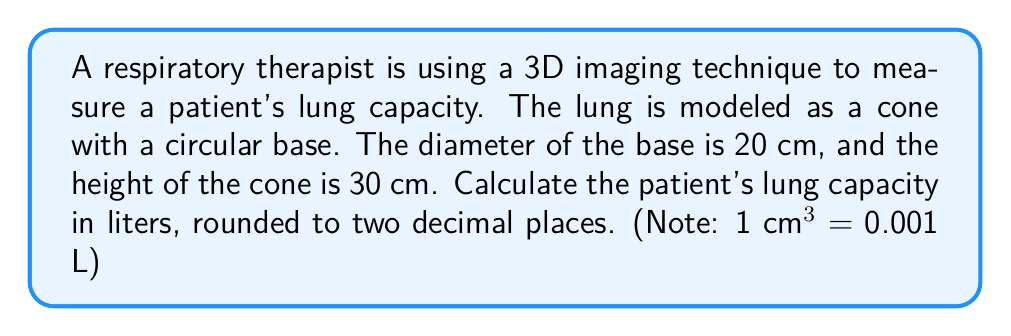Show me your answer to this math problem. To solve this problem, we need to follow these steps:

1) The volume of a cone is given by the formula:

   $$V = \frac{1}{3}\pi r^2 h$$

   where $r$ is the radius of the base and $h$ is the height of the cone.

2) We're given the diameter of the base, which is 20 cm. We need to find the radius:

   $$r = \frac{diameter}{2} = \frac{20}{2} = 10 \text{ cm}$$

3) The height $h$ is given as 30 cm.

4) Now we can substitute these values into our volume formula:

   $$V = \frac{1}{3}\pi (10\text{ cm})^2 (30\text{ cm})$$

5) Let's calculate this step by step:

   $$V = \frac{1}{3}\pi (100\text{ cm}^2) (30\text{ cm})$$
   $$V = 10\pi (100\text{ cm}^3)$$
   $$V = 1000\pi \text{ cm}^3$$

6) We can use 3.14159 as an approximation for $\pi$:

   $$V \approx 1000 (3.14159) \text{ cm}^3 = 3141.59 \text{ cm}^3$$

7) Now we need to convert this to liters. We're given that 1 cm³ = 0.001 L:

   $$3141.59 \text{ cm}^3 \times 0.001 \text{ L/cm}^3 = 3.14159 \text{ L}$$

8) Rounding to two decimal places:

   $$3.14 \text{ L}$$

Thus, the patient's lung capacity is approximately 3.14 liters.
Answer: 3.14 L 